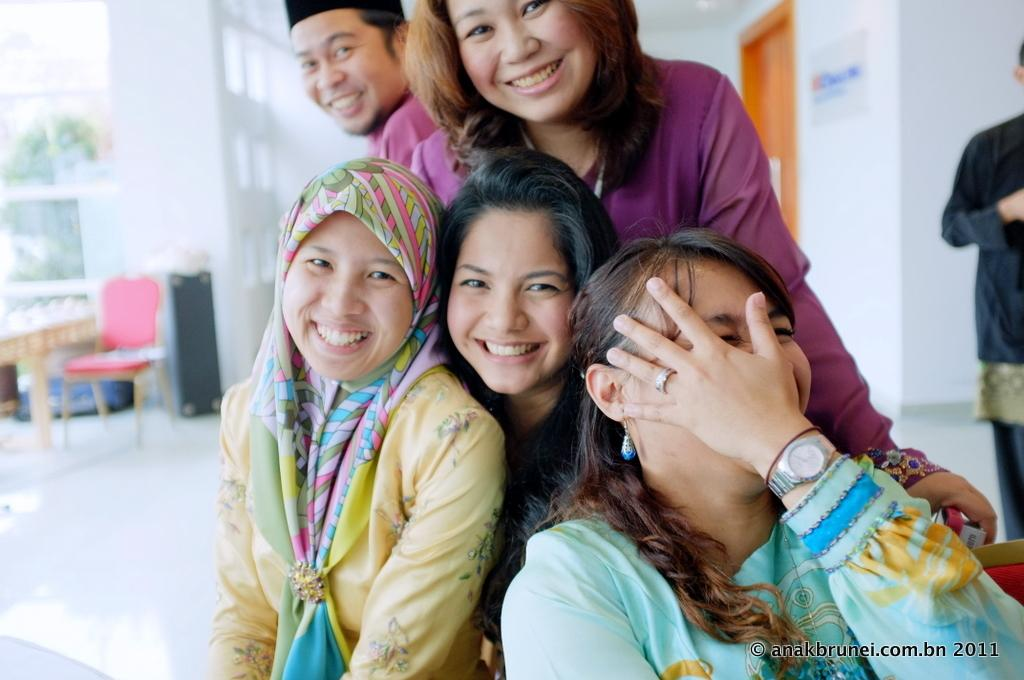How many people are in the image? There is a group of people in the image. What is the facial expression of the people in the image? The people are smiling. What is the surface beneath the people's feet in the image? There is a floor in the image. What type of furniture is present in the image? There is a chair in the image. What can be seen in the background of the image? There is a wall in the background of the image. What architectural feature is present in the image? There is a door in the image. What type of mountain can be seen in the background of the image? There is no mountain present in the image; it features a wall in the background. What bird is perched on the chair in the image? There is no bird present in the image; it only features a group of people, a floor, a chair, a wall, and a door. 